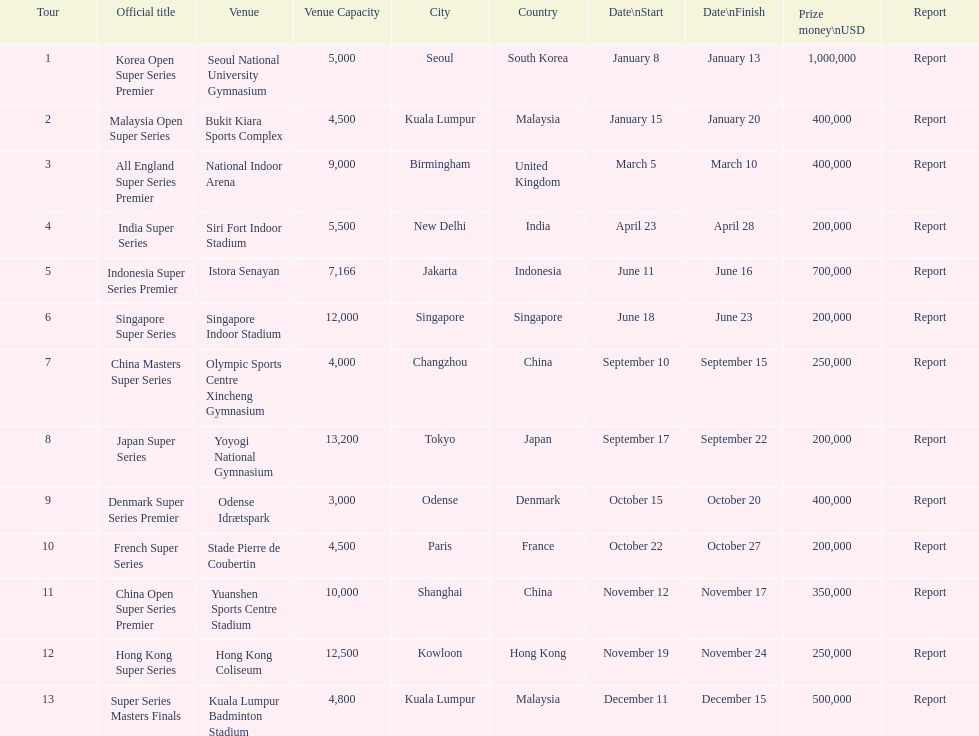Which tour was the only one to take place in december? Super Series Masters Finals. 